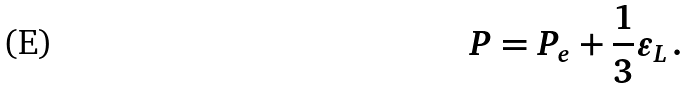Convert formula to latex. <formula><loc_0><loc_0><loc_500><loc_500>P = P _ { e } + \frac { 1 } { 3 } \varepsilon _ { L } \, .</formula> 